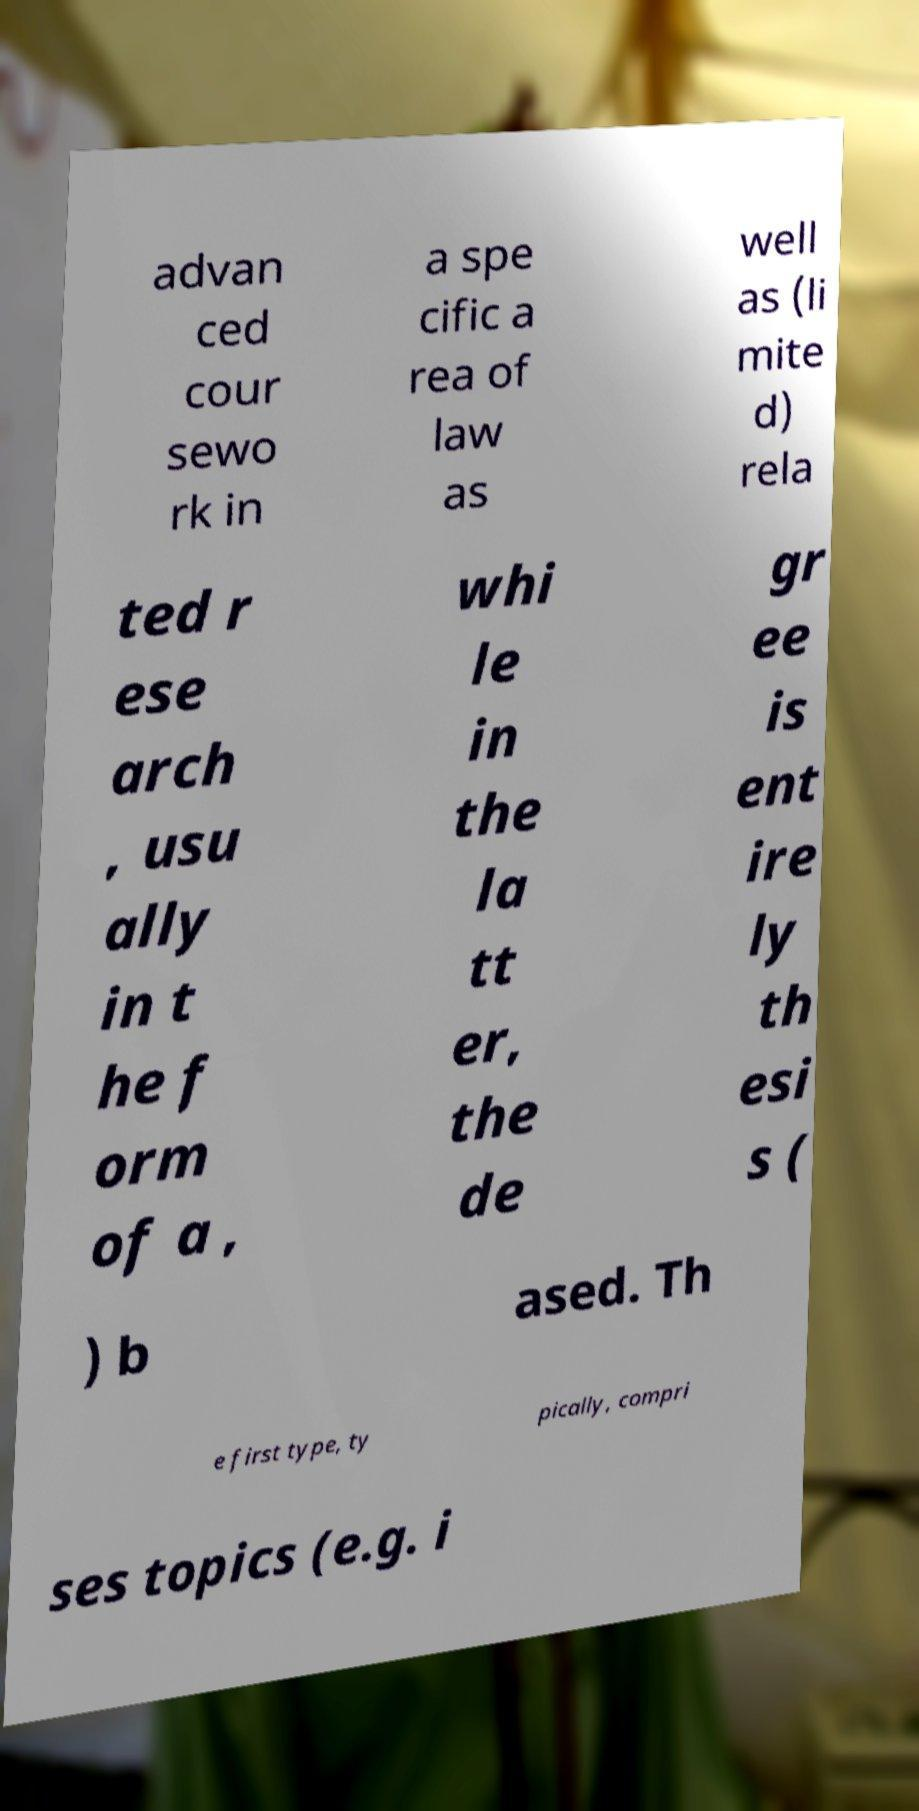What messages or text are displayed in this image? I need them in a readable, typed format. advan ced cour sewo rk in a spe cific a rea of law as well as (li mite d) rela ted r ese arch , usu ally in t he f orm of a , whi le in the la tt er, the de gr ee is ent ire ly th esi s ( ) b ased. Th e first type, ty pically, compri ses topics (e.g. i 